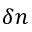<formula> <loc_0><loc_0><loc_500><loc_500>\delta n</formula> 